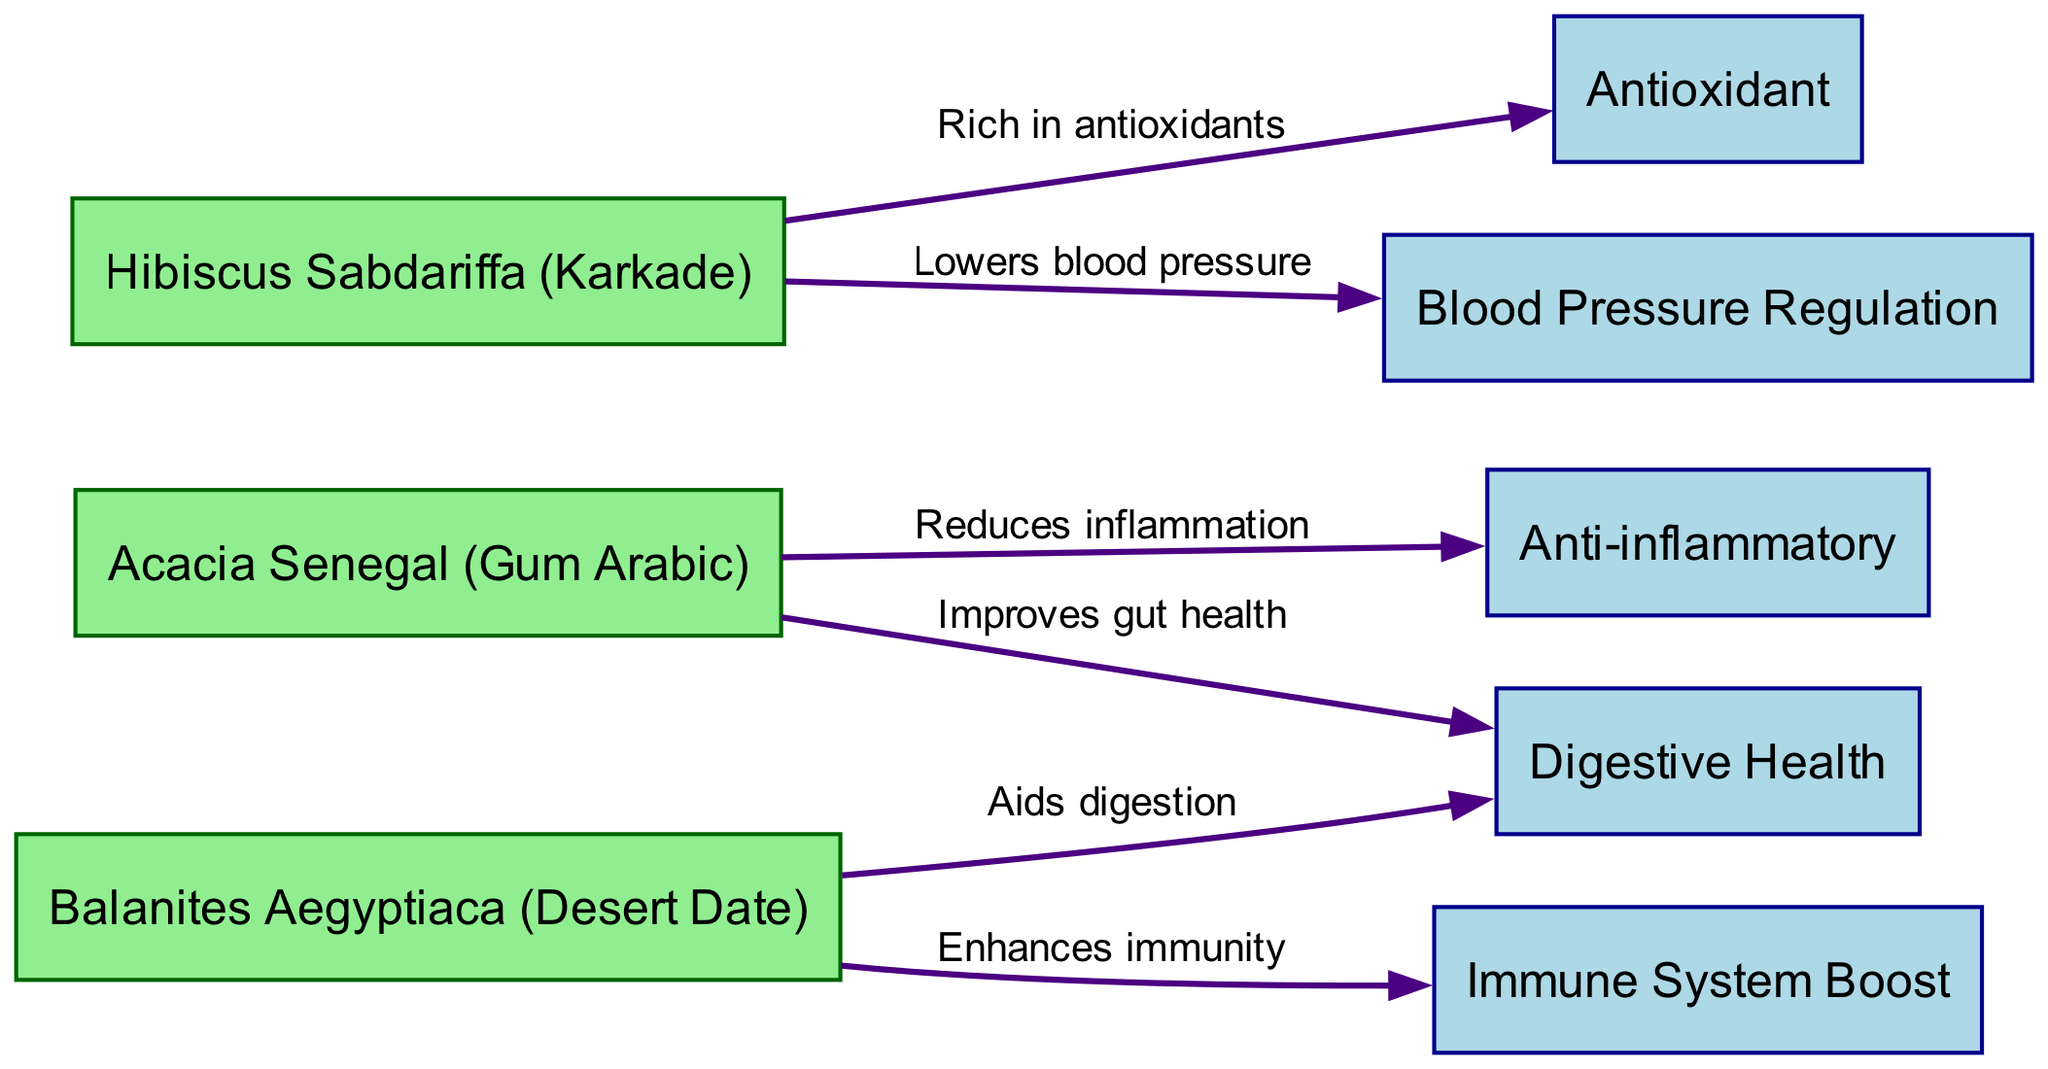What is the total number of plants in the diagram? The diagram lists three unique plants, which are Acacia Senegal (Gum Arabic), Hibiscus Sabdariffa (Karkade), and Balanites Aegyptiaca (Desert Date). Counting them gives a total of three plants.
Answer: 3 Which benefit is associated with Acacia Senegal? Acacia Senegal has two benefits associated with it in the diagram: it reduces inflammation and improves gut health. Therefore, any of these two benefits can be an answer; the question asks for one specific benefit, such as "Reduces inflammation."
Answer: Reduces inflammation How many benefits are highlighted in the diagram? The diagram shows five distinct benefits: Anti-inflammatory, Antioxidant, Digestive Health, Blood Pressure Regulation, and Immune System Boost. Counting these benefits gives a total of five.
Answer: 5 Which plant is known for enhancing immunity? Balanites Aegyptiaca is the plant specifically noted for enhancing immunity, as indicated in the diagram.
Answer: Balanites Aegyptiaca What is the relationship between Hibiscus Sabdariffa and Blood Pressure Regulation? Hibiscus Sabdariffa is shown to lower blood pressure according to the edges connecting the nodes in the diagram. The relationship is that it directly contributes to blood pressure regulation.
Answer: Lowers blood pressure What are the benefits associated with Balanites Aegyptiaca? The diagram shows that Balanites Aegyptiaca is linked to two benefits: it enhances immunity and aids digestion. Therefore, the answer can refer to either or both benefits.
Answer: Enhances immunity, Aids digestion Which plant has antioxidant properties? The infographic states that Hibiscus Sabdariffa is rich in antioxidants, making it the plant associated with antioxidant properties.
Answer: Hibiscus Sabdariffa How many edges connect the plants to their benefits? The total number of edges in the diagram, representing connections between plants and benefits, is six, based on the edges listed between nodes.
Answer: 6 